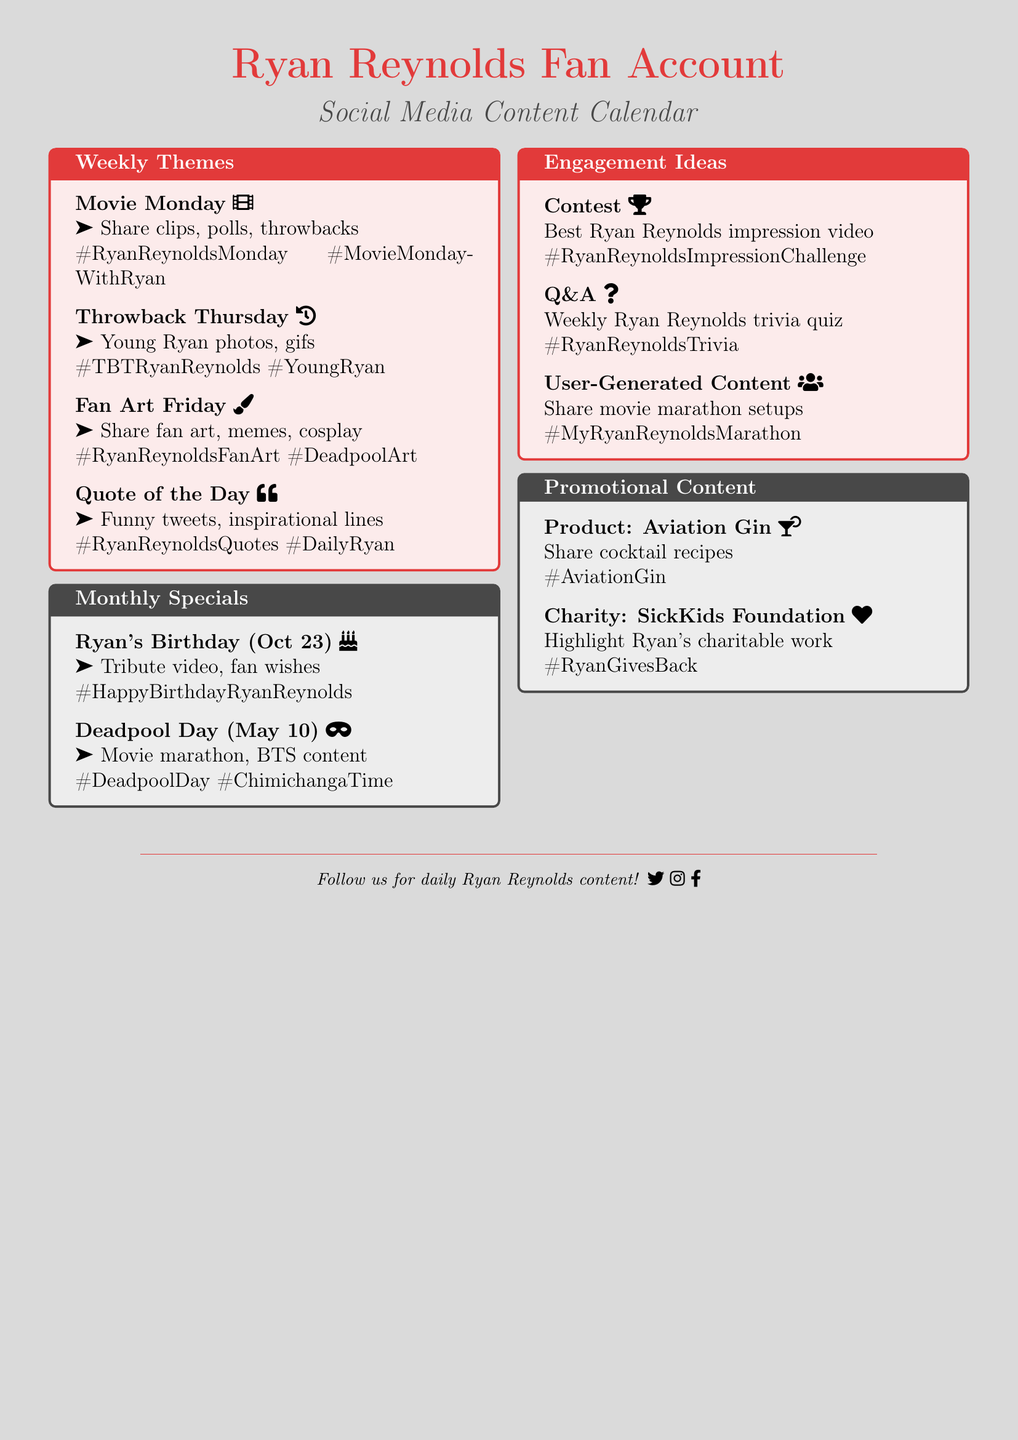What is the theme of the weekly social media posts on Mondays? The theme for Monday is "Movie Monday," focusing on movie-related content featuring Ryan Reynolds.
Answer: Movie Monday What date is Ryan Reynolds' birthday? Ryan Reynolds' birthday is mentioned as October 23 in the document.
Answer: October 23 What is one of the engagement ideas listed? The document lists various engagement ideas, including contests and trivia quizzes, as well as user-generated content prompts.
Answer: Contest What are the hashtags associated with Fan Art Friday? The hashtags associated with Fan Art Friday are specified in the document.
Answer: #RyanReynoldsFanArt, #DeadpoolArt, #RyanReynoldsCosplay What special event is celebrated on May 10? The document specifies that Deadpool Day is celebrated on May 10.
Answer: Deadpool Day How many weekly themes are outlined in the document? The document outlines four weekly themes for social media posts.
Answer: Four What type of promotional content is highlighted related to charity? The document includes promotional content focusing on Ryan's involvement with SickKids Foundation.
Answer: Charity What activity is suggested for Deadpool Day? One of the activities suggested for Deadpool Day is to host a movie marathon watch-along.
Answer: Movie marathon watch-along What type of content is associated with the hashtag #RyanReynoldsQuotes? This hashtag pertains to quotes made by Ryan Reynolds, including funny tweets and inspirational lines.
Answer: Quotes 